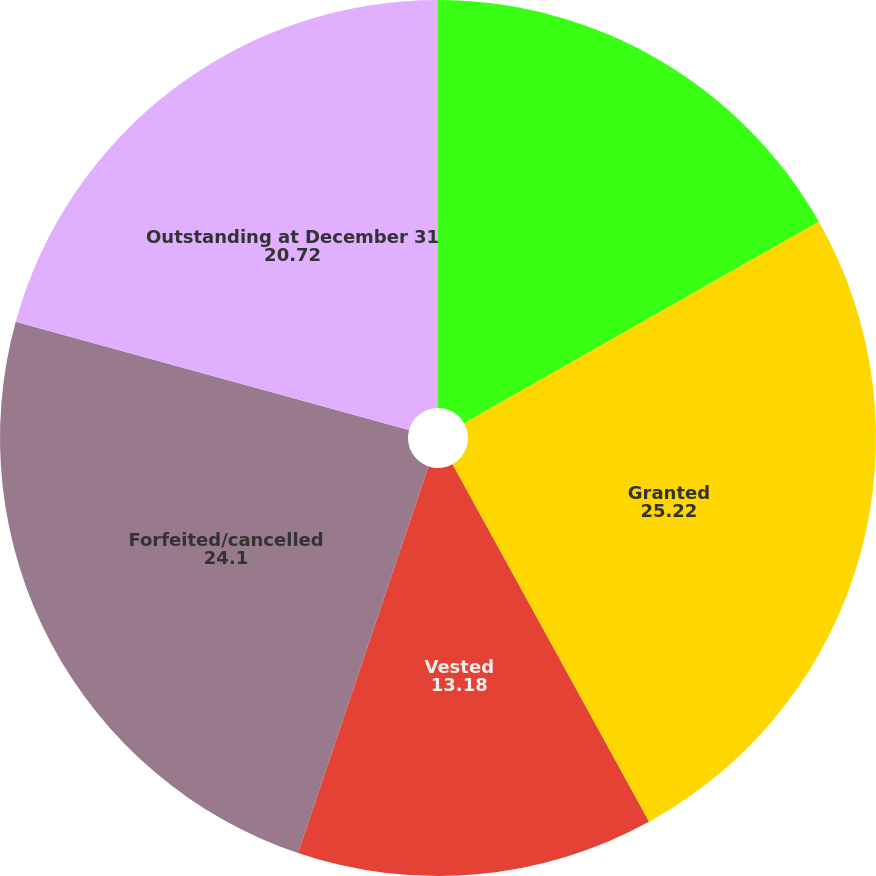<chart> <loc_0><loc_0><loc_500><loc_500><pie_chart><fcel>Outstanding at January 1 2016<fcel>Granted<fcel>Vested<fcel>Forfeited/cancelled<fcel>Outstanding at December 31<nl><fcel>16.78%<fcel>25.22%<fcel>13.18%<fcel>24.1%<fcel>20.72%<nl></chart> 